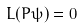Convert formula to latex. <formula><loc_0><loc_0><loc_500><loc_500>L ( P \psi ) = 0</formula> 